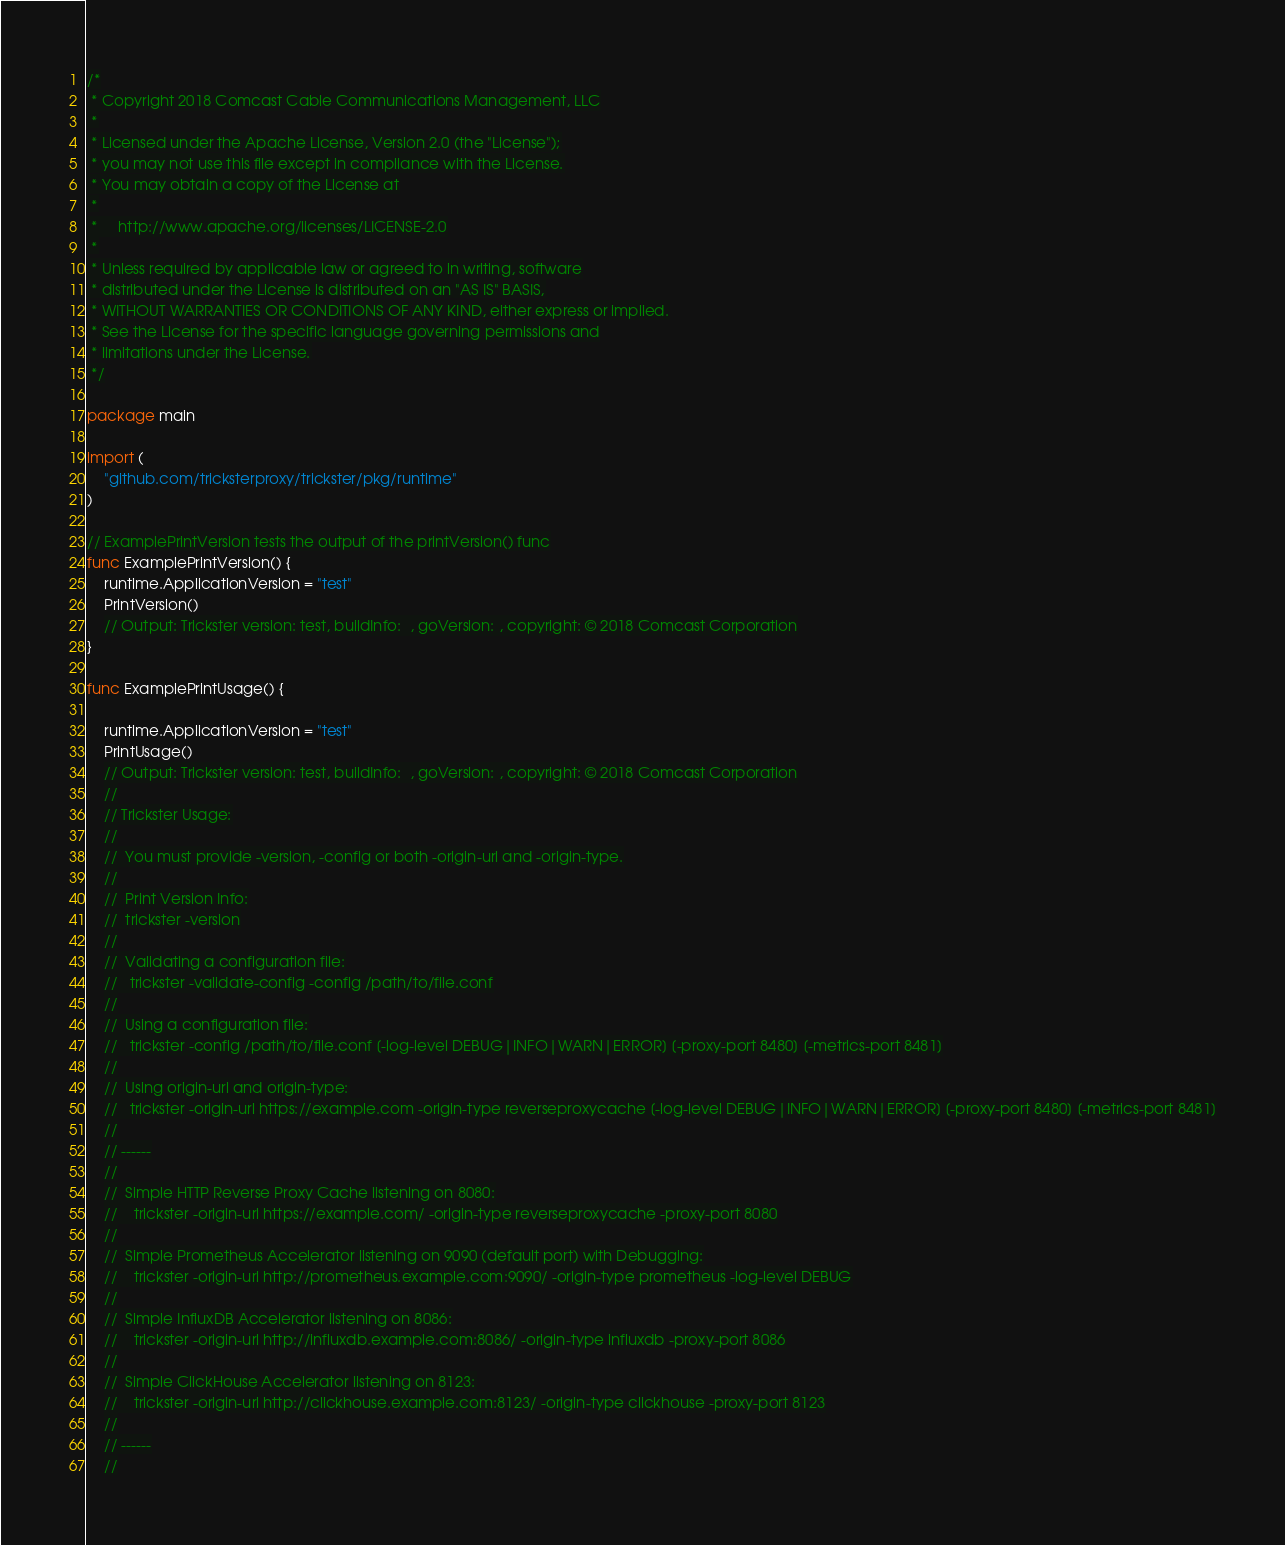<code> <loc_0><loc_0><loc_500><loc_500><_Go_>/*
 * Copyright 2018 Comcast Cable Communications Management, LLC
 *
 * Licensed under the Apache License, Version 2.0 (the "License");
 * you may not use this file except in compliance with the License.
 * You may obtain a copy of the License at
 *
 *     http://www.apache.org/licenses/LICENSE-2.0
 *
 * Unless required by applicable law or agreed to in writing, software
 * distributed under the License is distributed on an "AS IS" BASIS,
 * WITHOUT WARRANTIES OR CONDITIONS OF ANY KIND, either express or implied.
 * See the License for the specific language governing permissions and
 * limitations under the License.
 */

package main

import (
	"github.com/tricksterproxy/trickster/pkg/runtime"
)

// ExamplePrintVersion tests the output of the printVersion() func
func ExamplePrintVersion() {
	runtime.ApplicationVersion = "test"
	PrintVersion()
	// Output: Trickster version: test, buildInfo:  , goVersion: , copyright: © 2018 Comcast Corporation
}

func ExamplePrintUsage() {

	runtime.ApplicationVersion = "test"
	PrintUsage()
	// Output: Trickster version: test, buildInfo:  , goVersion: , copyright: © 2018 Comcast Corporation
	//
	// Trickster Usage:
	//
	//  You must provide -version, -config or both -origin-url and -origin-type.
	//
	//  Print Version Info:
	//  trickster -version
	//
	//  Validating a configuration file:
	//   trickster -validate-config -config /path/to/file.conf
	//
	//  Using a configuration file:
	//   trickster -config /path/to/file.conf [-log-level DEBUG|INFO|WARN|ERROR] [-proxy-port 8480] [-metrics-port 8481]
	//
	//  Using origin-url and origin-type:
	//   trickster -origin-url https://example.com -origin-type reverseproxycache [-log-level DEBUG|INFO|WARN|ERROR] [-proxy-port 8480] [-metrics-port 8481]
	//
	// ------
	//
	//  Simple HTTP Reverse Proxy Cache listening on 8080:
	//    trickster -origin-url https://example.com/ -origin-type reverseproxycache -proxy-port 8080
	//
	//  Simple Prometheus Accelerator listening on 9090 (default port) with Debugging:
	//    trickster -origin-url http://prometheus.example.com:9090/ -origin-type prometheus -log-level DEBUG
	//
	//  Simple InfluxDB Accelerator listening on 8086:
	//    trickster -origin-url http://influxdb.example.com:8086/ -origin-type influxdb -proxy-port 8086
	//
	//  Simple ClickHouse Accelerator listening on 8123:
	//    trickster -origin-url http://clickhouse.example.com:8123/ -origin-type clickhouse -proxy-port 8123
	//
	// ------
	//</code> 